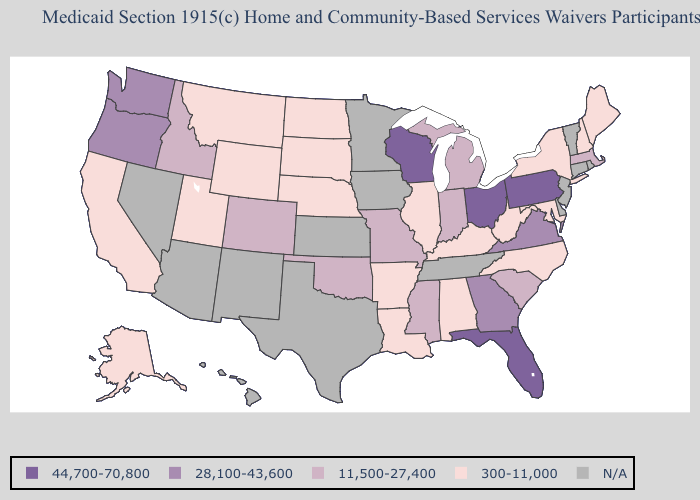What is the highest value in the Northeast ?
Be succinct. 44,700-70,800. What is the lowest value in the USA?
Be succinct. 300-11,000. How many symbols are there in the legend?
Give a very brief answer. 5. Does Ohio have the highest value in the USA?
Keep it brief. Yes. What is the highest value in states that border Virginia?
Be succinct. 300-11,000. Does Maine have the highest value in the USA?
Keep it brief. No. Among the states that border Maryland , does West Virginia have the highest value?
Give a very brief answer. No. What is the highest value in the USA?
Write a very short answer. 44,700-70,800. Name the states that have a value in the range 28,100-43,600?
Answer briefly. Georgia, Oregon, Virginia, Washington. Does Ohio have the highest value in the USA?
Quick response, please. Yes. Among the states that border Maryland , which have the highest value?
Concise answer only. Pennsylvania. Name the states that have a value in the range N/A?
Short answer required. Arizona, Connecticut, Delaware, Hawaii, Iowa, Kansas, Minnesota, Nevada, New Jersey, New Mexico, Rhode Island, Tennessee, Texas, Vermont. What is the lowest value in the West?
Answer briefly. 300-11,000. 